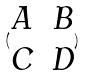Convert formula to latex. <formula><loc_0><loc_0><loc_500><loc_500>( \begin{matrix} A & B \\ C & D \end{matrix} )</formula> 